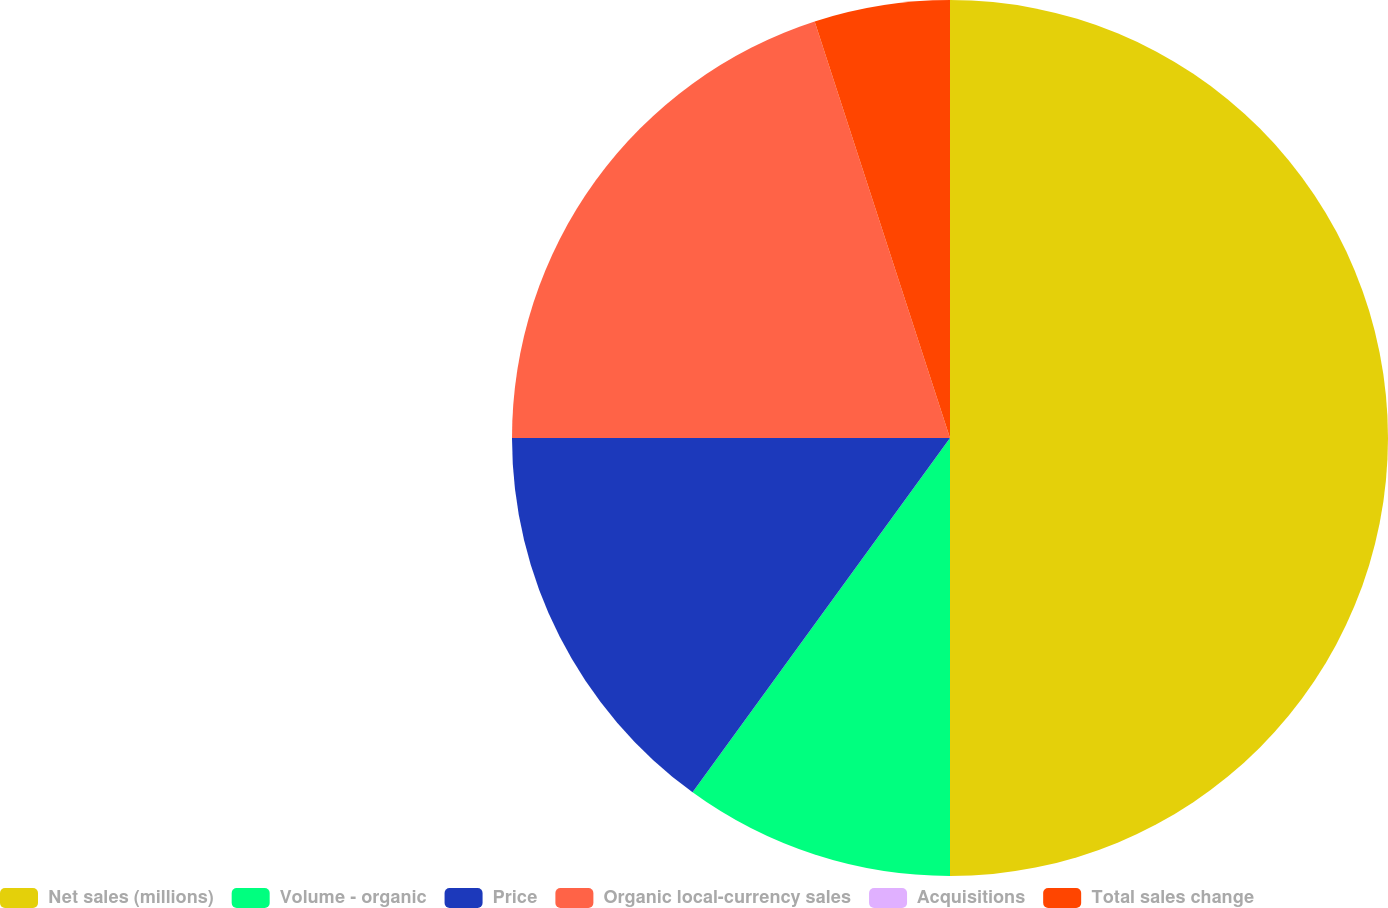<chart> <loc_0><loc_0><loc_500><loc_500><pie_chart><fcel>Net sales (millions)<fcel>Volume - organic<fcel>Price<fcel>Organic local-currency sales<fcel>Acquisitions<fcel>Total sales change<nl><fcel>50.0%<fcel>10.0%<fcel>15.0%<fcel>20.0%<fcel>0.0%<fcel>5.0%<nl></chart> 